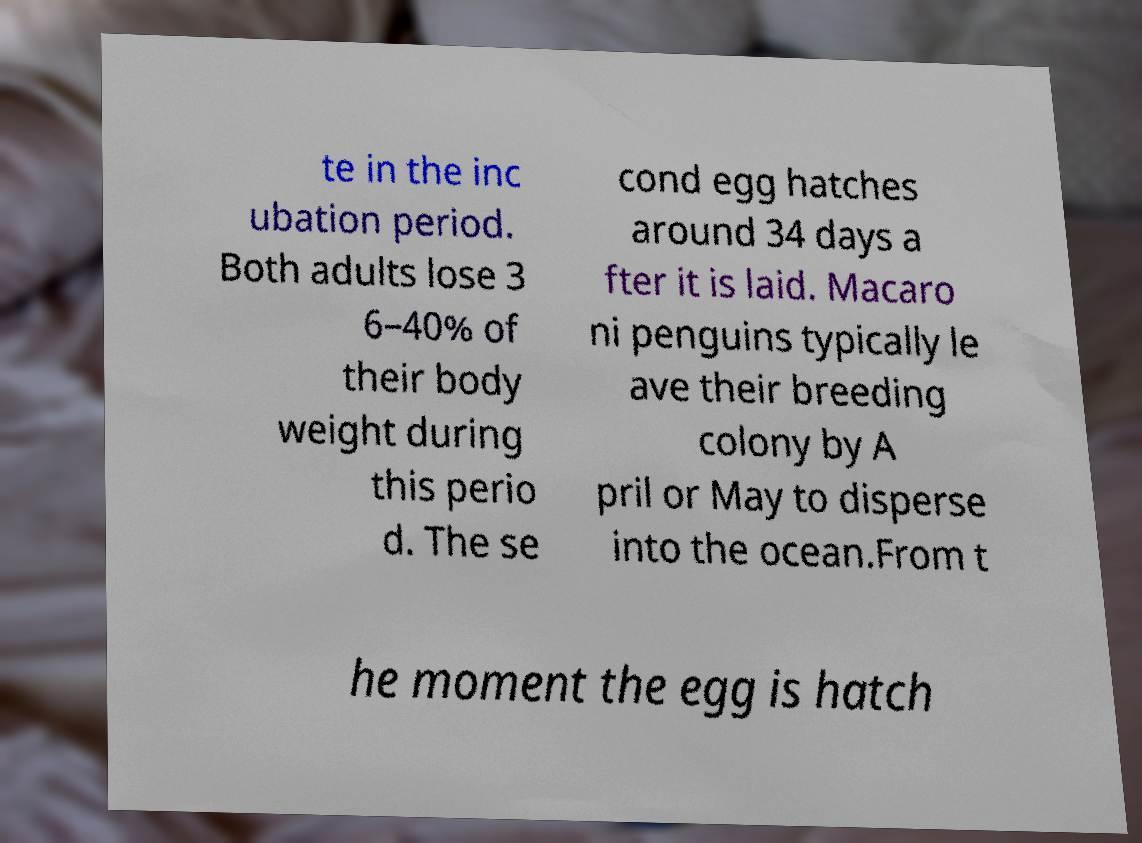Can you accurately transcribe the text from the provided image for me? te in the inc ubation period. Both adults lose 3 6–40% of their body weight during this perio d. The se cond egg hatches around 34 days a fter it is laid. Macaro ni penguins typically le ave their breeding colony by A pril or May to disperse into the ocean.From t he moment the egg is hatch 